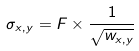Convert formula to latex. <formula><loc_0><loc_0><loc_500><loc_500>\sigma _ { x , y } = F \times \frac { 1 } { \sqrt { w _ { x , y } } }</formula> 